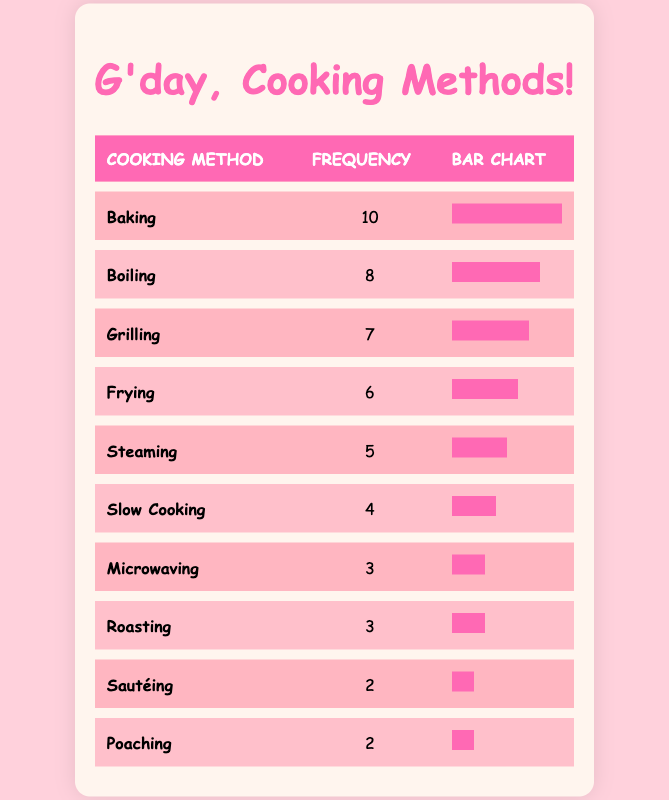What is the most common cooking method? The table lists the cooking methods and their frequencies. The method with the highest frequency is "Baking," which has a frequency of 10.
Answer: Baking How many times is "Microwaving" used? The frequency of the "Microwaving" method is provided directly in the table as 3.
Answer: 3 What is the frequency of "Grilling" compared to "Frying"? "Grilling" has a frequency of 7, while "Frying" has a frequency of 6. So, "Grilling" is used 1 more time than "Frying" (7 - 6 = 1).
Answer: 1 Is "Steaming" used more frequently than "Slow Cooking"? The frequency for "Steaming" is 5, whereas for "Slow Cooking," it is 4. Since 5 is greater than 4, yes, "Steaming" is used more frequently.
Answer: Yes What is the total frequency of all cooking methods combined? To find the total frequency, we add all the frequencies: (10 + 8 + 7 + 6 + 5 + 4 + 3 + 3 + 2 + 2) = 50.
Answer: 50 Which cooking methods have the same frequency? The table shows that "Microwaving" and "Roasting" both have a frequency of 3, while "Sautéing" and "Poaching" both have a frequency of 2.
Answer: Microwaving and Roasting, Sautéing and Poaching What is the difference in frequency between the most common and the least common cooking method? The most common method is "Baking" with a frequency of 10, and the least common method is "Sautéing" or "Poaching," both with a frequency of 2. The difference is 10 - 2 = 8.
Answer: 8 What percentage of cooking methods are used more than 5 times? The methods used more than 5 times are "Baking" (10), "Boiling" (8), and "Grilling" (7). That's 3 methods out of 10 total methods, which is (3/10)*100 = 30%.
Answer: 30% How many cooking methods are used less frequently than 5 times? The methods with less than 5 frequency are "Slow Cooking" (4), "Microwaving" (3), "Roasting" (3), "Sautéing" (2), and "Poaching" (2). This counts to 5 methods in total.
Answer: 5 